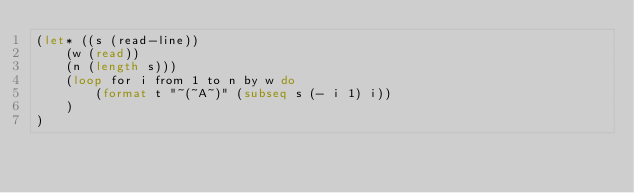<code> <loc_0><loc_0><loc_500><loc_500><_Lisp_>(let* ((s (read-line))
    (w (read))
    (n (length s)))
    (loop for i from 1 to n by w do
        (format t "~(~A~)" (subseq s (- i 1) i))
    )
)</code> 